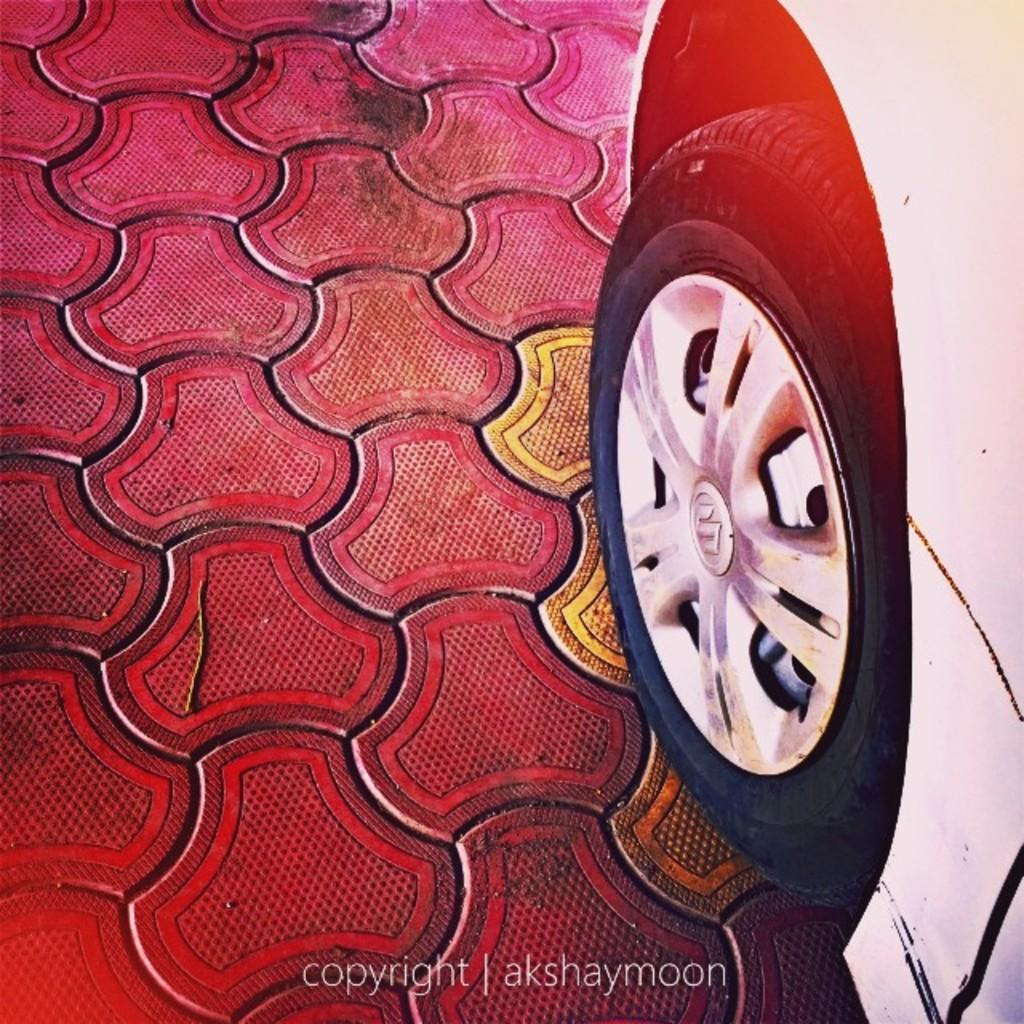What vehicle is located on the right side of the image? There is a car on the right side of the image. What surface is visible at the bottom of the image? There is a floor visible at the bottom of the image. What type of mitten is being used by the committee in the image? There is no committee or mitten present in the image. What is the kettle used for in the image? There is no kettle present in the image. 